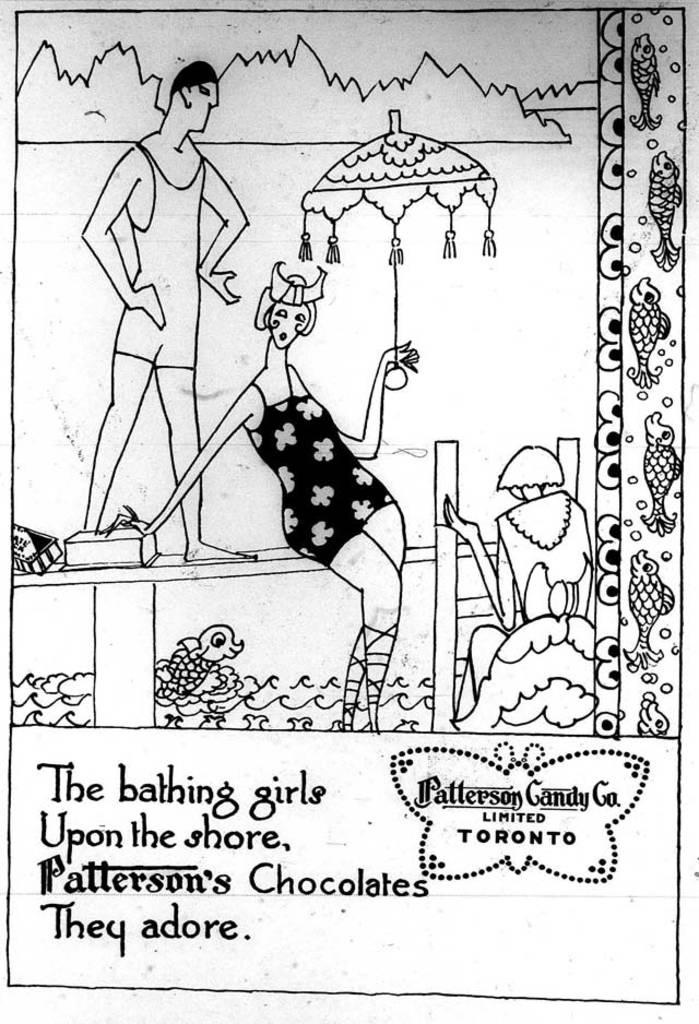What is depicted on the white surface in the image? There is a sketch and text on the white surface. Can you describe the sketch on the white surface? Unfortunately, the details of the sketch cannot be determined from the image alone. What does the text on the white surface say? The content of the text cannot be determined from the image alone. How many bulbs are present in the image? There are no bulbs present in the image; it only features a sketch and text on a white surface. What type of beetle can be seen crawling on the sketch? There is no beetle present in the image; it only features a sketch and text on a white surface. 